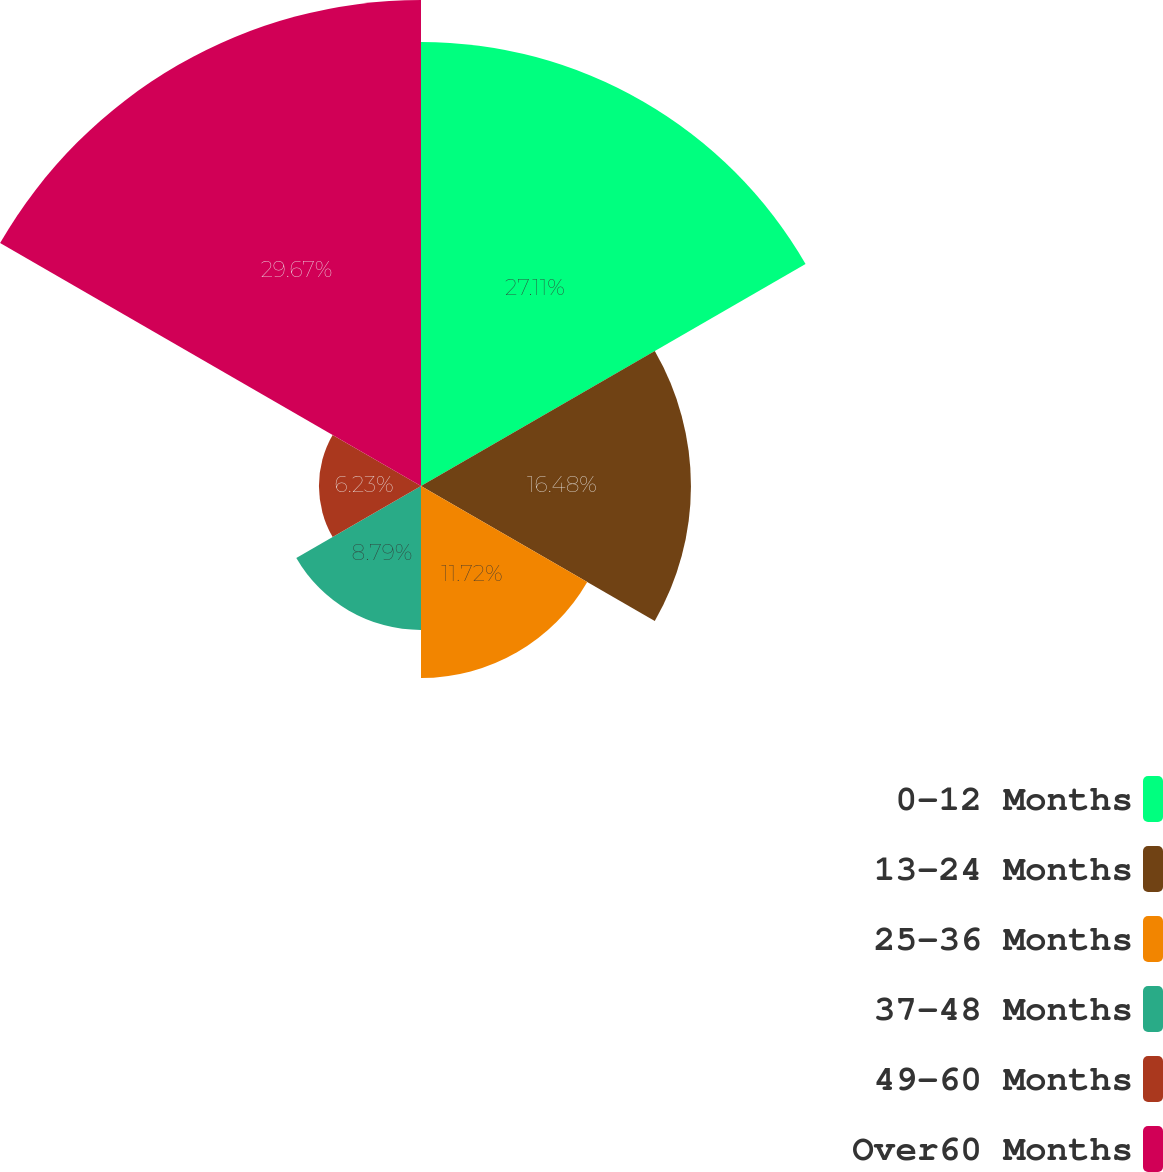Convert chart. <chart><loc_0><loc_0><loc_500><loc_500><pie_chart><fcel>0-12 Months<fcel>13-24 Months<fcel>25-36 Months<fcel>37-48 Months<fcel>49-60 Months<fcel>Over60 Months<nl><fcel>27.11%<fcel>16.48%<fcel>11.72%<fcel>8.79%<fcel>6.23%<fcel>29.67%<nl></chart> 